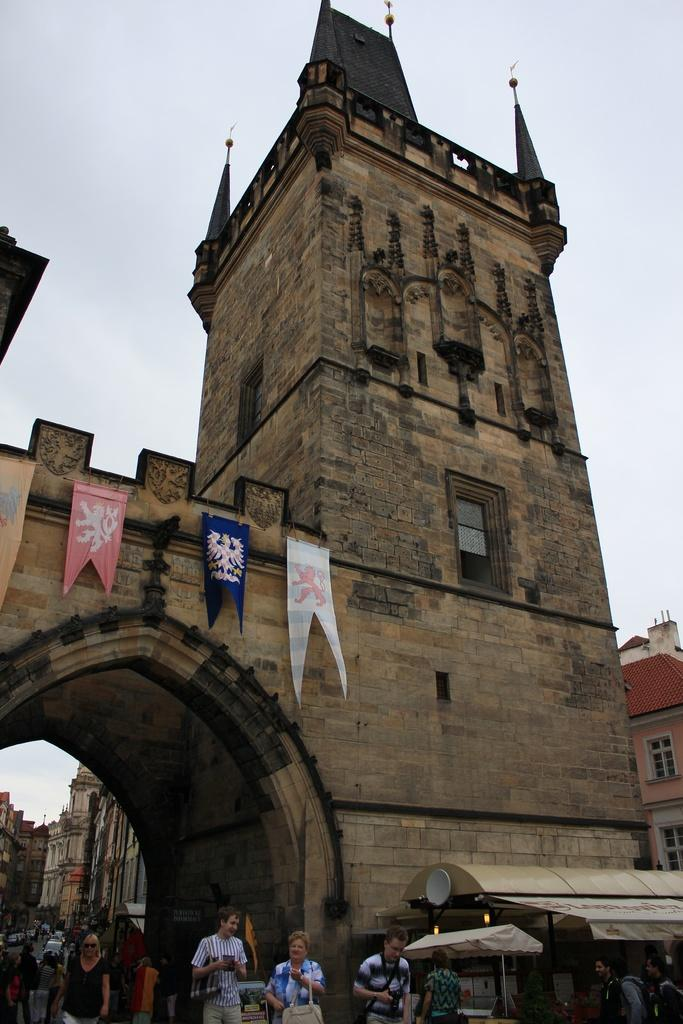What are the people in the image doing? There are persons walking in the image. What structures can be seen in the image? There are buildings in the image. What decorations are on the buildings? Flags are hanging on the walls of the buildings. How would you describe the weather in the image? The sky is cloudy in the image. What architectural feature is present in the image? There is an arch in the image. What temporary shelters can be seen in the image? There are tents in the image. What flavor of ice cream is being served at the committee meeting in the image? There is no ice cream or committee meeting present in the image. What month is it in the image? The image does not provide any information about the month. 